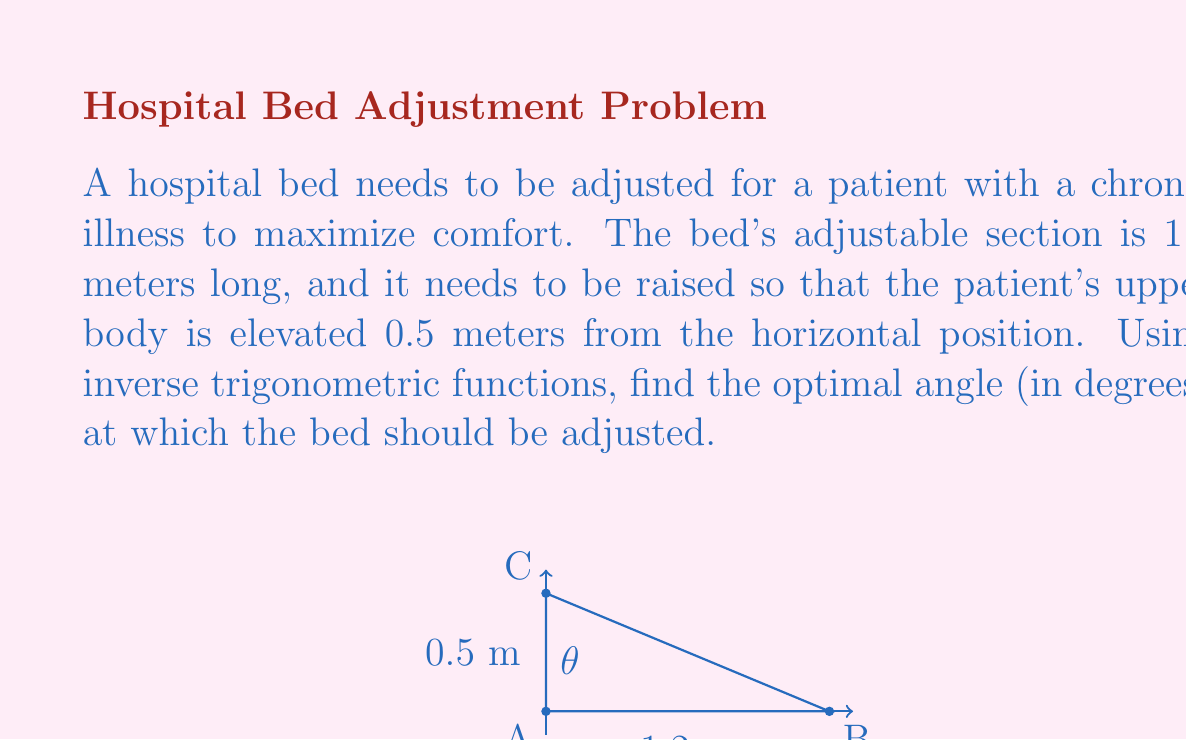What is the answer to this math problem? Let's approach this step-by-step:

1) We can visualize this problem as a right-angled triangle, where:
   - The base of the triangle is the length of the bed's adjustable section (1.2 m)
   - The height is the elevation of the patient's upper body (0.5 m)
   - The angle we're looking for is between the base and the hypotenuse

2) To find this angle, we can use the inverse tangent function (arctan or $\tan^{-1}$)

3) In a right-angled triangle, $\tan(\theta) = \frac{\text{opposite}}{\text{adjacent}}$

4) In our case:
   $\tan(\theta) = \frac{0.5}{1.2}$

5) To find $\theta$, we take the inverse tangent of both sides:
   $\theta = \tan^{-1}(\frac{0.5}{1.2})$

6) Using a calculator or computer:
   $\theta = \tan^{-1}(0.4166667) \approx 22.6199$ degrees

7) Rounding to one decimal place for practical use:
   $\theta \approx 22.6$ degrees

Therefore, the optimal angle for adjusting the hospital bed is approximately 22.6 degrees.
Answer: $22.6°$ 